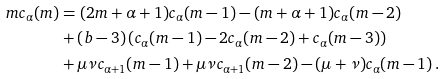Convert formula to latex. <formula><loc_0><loc_0><loc_500><loc_500>m c _ { \alpha } ( m ) & = ( 2 m + \alpha + 1 ) c _ { \alpha } ( m - 1 ) - ( m + \alpha + 1 ) c _ { \alpha } ( m - 2 ) \\ & + ( b - 3 ) \left ( c _ { \alpha } ( m - 1 ) - 2 c _ { \alpha } ( m - 2 ) + c _ { \alpha } ( m - 3 ) \right ) \\ & + \mu \nu c _ { \alpha + 1 } ( m - 1 ) + \mu \nu c _ { \alpha + 1 } ( m - 2 ) - ( \mu + \nu ) c _ { \alpha } ( m - 1 ) \, .</formula> 